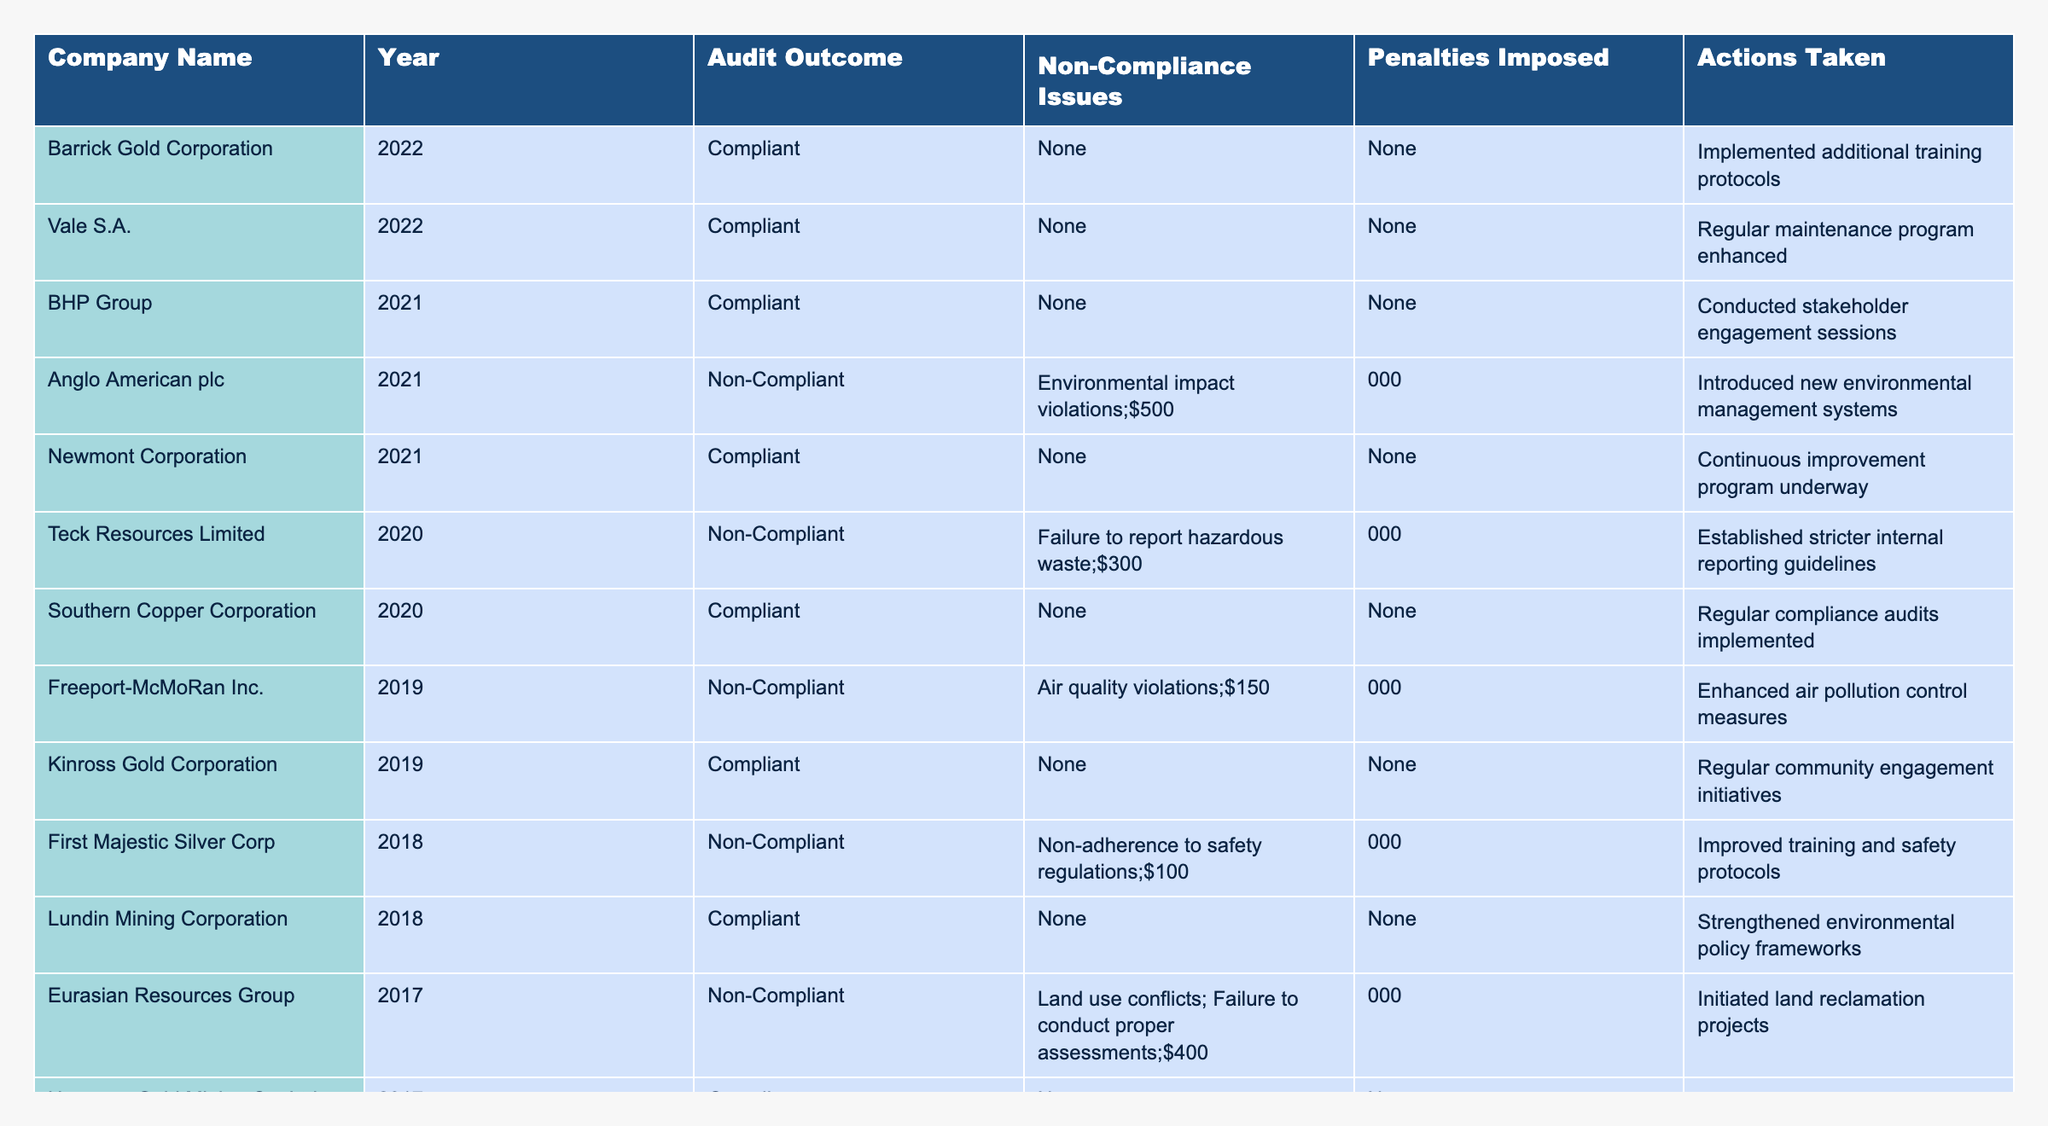What was the outcome of the audit for Barrick Gold Corporation in 2022? The table shows that Barrick Gold Corporation's audit outcome for 2022 is "Compliant."
Answer: Compliant How many companies were non-compliant in 2021? In 2021, the table lists two companies that were non-compliant: Anglo American plc and Newmont Corporation.
Answer: 1 What penalty was imposed on Teck Resources Limited? According to the table, Teck Resources Limited faced a penalty of $300,000 for their non-compliance regarding hazardous waste reporting.
Answer: $300,000 Which company had the highest penalty and what was the reason? The highest penalty was $500,000 imposed on Anglo American plc for environmental impact violations.
Answer: $500,000, environmental impact violations Which companies were compliant in 2020? The table shows that Southern Copper Corporation was compliant in 2020.
Answer: Southern Copper Corporation What were the actions taken by companies that were non-compliant? For each non-compliant company, specific actions are listed: introducing new management systems, establishing stricter guidelines, enhancing control measures, and improving safety protocols.
Answer: Various actions including new management systems and safety improvements What is the total penalty amount imposed on all non-compliant companies across the years? Adding the penalties gives: $500,000 (Anglo American) + $300,000 (Teck Resources) + $150,000 (Freeport-McMoRan) + $100,000 (First Majestic Silver) + $400,000 (Eurasian Resources) + $250,000 (Gold Fields) = $1,700,000.
Answer: $1,700,000 Was Freeport-McMoRan compliant in 2019 or 2020? The table shows that Freeport-McMoRan was non-compliant in 2019 and does not have a record for 2020.
Answer: No What common actions were taken by compliant companies to improve their practices? Compliant companies often took actions like implementing continuous improvement programs or enhancing training protocols to maintain compliance.
Answer: Training and improvement initiatives Which year saw the most non-compliance issues listed, and what were they? In 2017, there were multiple non-compliance issues for Eurasian Resources Group, including land use conflicts and failure to conduct proper assessments.
Answer: 2017; land use conflicts, failure to conduct assessments How does the number of compliant companies compare to non-compliant ones in 2018? The table indicates there were three compliant companies and one non-compliant company in 2018.
Answer: More compliant (3 compliant, 1 non-compliant) 